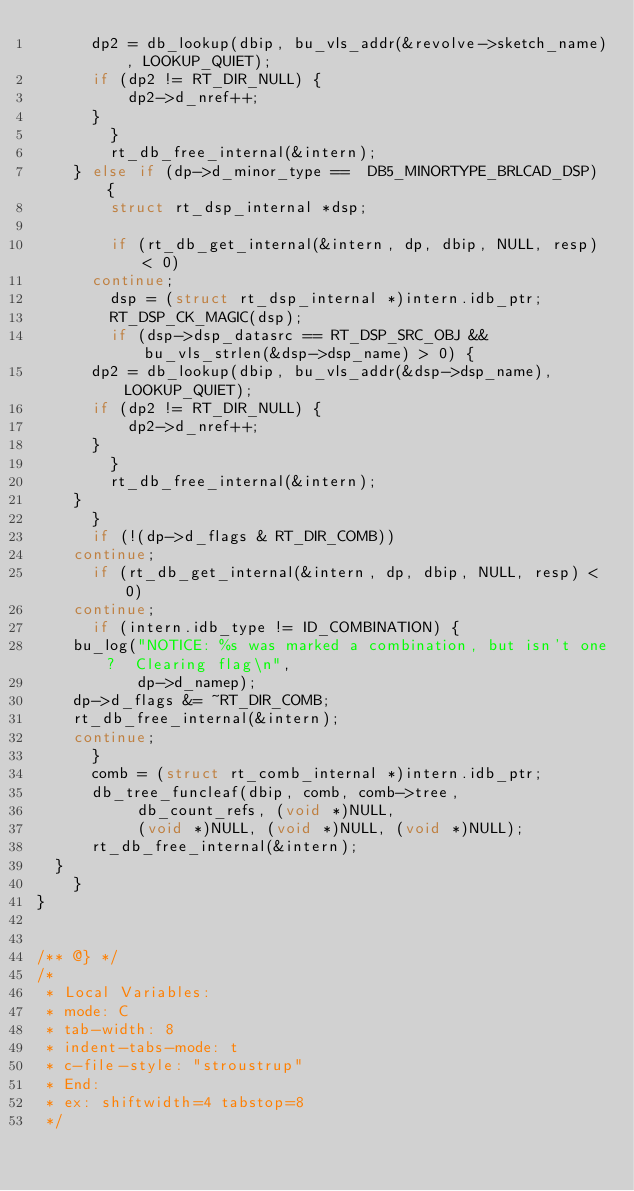Convert code to text. <code><loc_0><loc_0><loc_500><loc_500><_C_>			dp2 = db_lookup(dbip, bu_vls_addr(&revolve->sketch_name), LOOKUP_QUIET);
			if (dp2 != RT_DIR_NULL) {
			    dp2->d_nref++;
			}
		    }
		    rt_db_free_internal(&intern);
		} else if (dp->d_minor_type ==  DB5_MINORTYPE_BRLCAD_DSP) {
		    struct rt_dsp_internal *dsp;

		    if (rt_db_get_internal(&intern, dp, dbip, NULL, resp) < 0)
			continue;
		    dsp = (struct rt_dsp_internal *)intern.idb_ptr;
		    RT_DSP_CK_MAGIC(dsp);
		    if (dsp->dsp_datasrc == RT_DSP_SRC_OBJ && bu_vls_strlen(&dsp->dsp_name) > 0) {
			dp2 = db_lookup(dbip, bu_vls_addr(&dsp->dsp_name), LOOKUP_QUIET);
			if (dp2 != RT_DIR_NULL) {
			    dp2->d_nref++;
			}
		    }
		    rt_db_free_internal(&intern);
		}
	    }
	    if (!(dp->d_flags & RT_DIR_COMB))
		continue;
	    if (rt_db_get_internal(&intern, dp, dbip, NULL, resp) < 0)
		continue;
	    if (intern.idb_type != ID_COMBINATION) {
		bu_log("NOTICE: %s was marked a combination, but isn't one?  Clearing flag\n",
		       dp->d_namep);
		dp->d_flags &= ~RT_DIR_COMB;
		rt_db_free_internal(&intern);
		continue;
	    }
	    comb = (struct rt_comb_internal *)intern.idb_ptr;
	    db_tree_funcleaf(dbip, comb, comb->tree,
			     db_count_refs, (void *)NULL,
			     (void *)NULL, (void *)NULL, (void *)NULL);
	    rt_db_free_internal(&intern);
	}
    }
}


/** @} */
/*
 * Local Variables:
 * mode: C
 * tab-width: 8
 * indent-tabs-mode: t
 * c-file-style: "stroustrup"
 * End:
 * ex: shiftwidth=4 tabstop=8
 */
</code> 